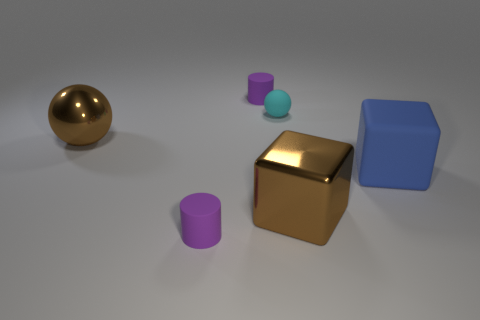How might the shadowing in the image give clues about the light source? The shadows in the image are soft and extend mostly to the right of the objects, indicating that the light source is to the left of the scene. The light does not seem to be very harsh, given the gentleness of the shadows, which suggests it may be diffused or indirect. The shadows also help to provide a sense of depth and dimension to the objects, emphasizing their shapes. 